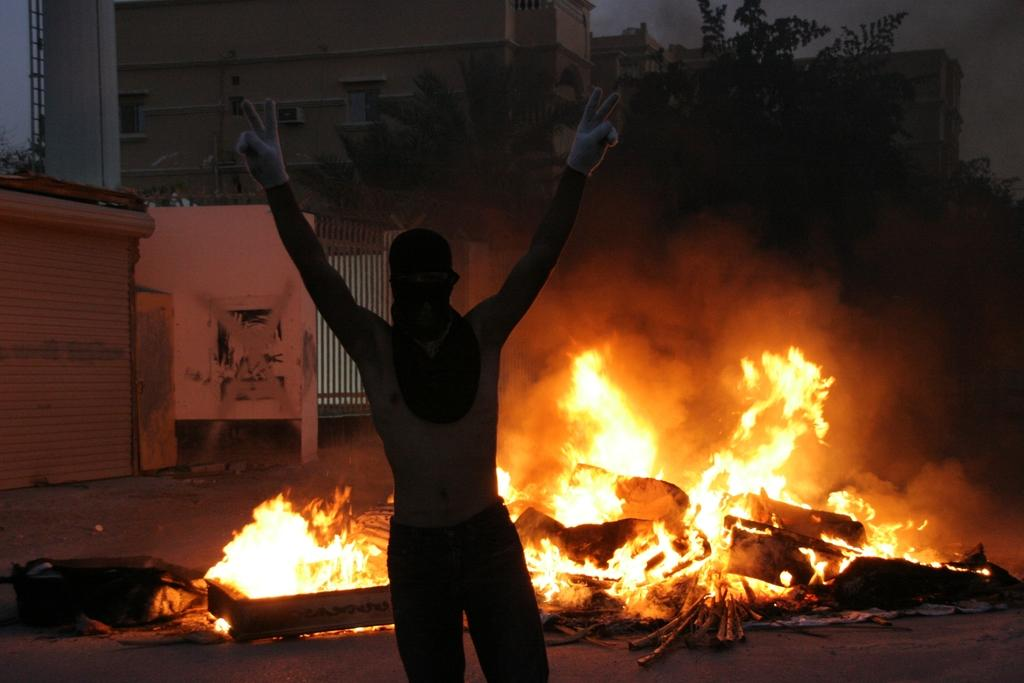Who or what is the main subject in the image? There is a person in the middle of the image. What is happening behind the person? There is fire visible behind the person. What can be seen in the distance in the image? There are trees and buildings in the background of the image. What is the cause of the ocean in the image? There is no ocean present in the image; it features a person, fire, trees, and buildings. 